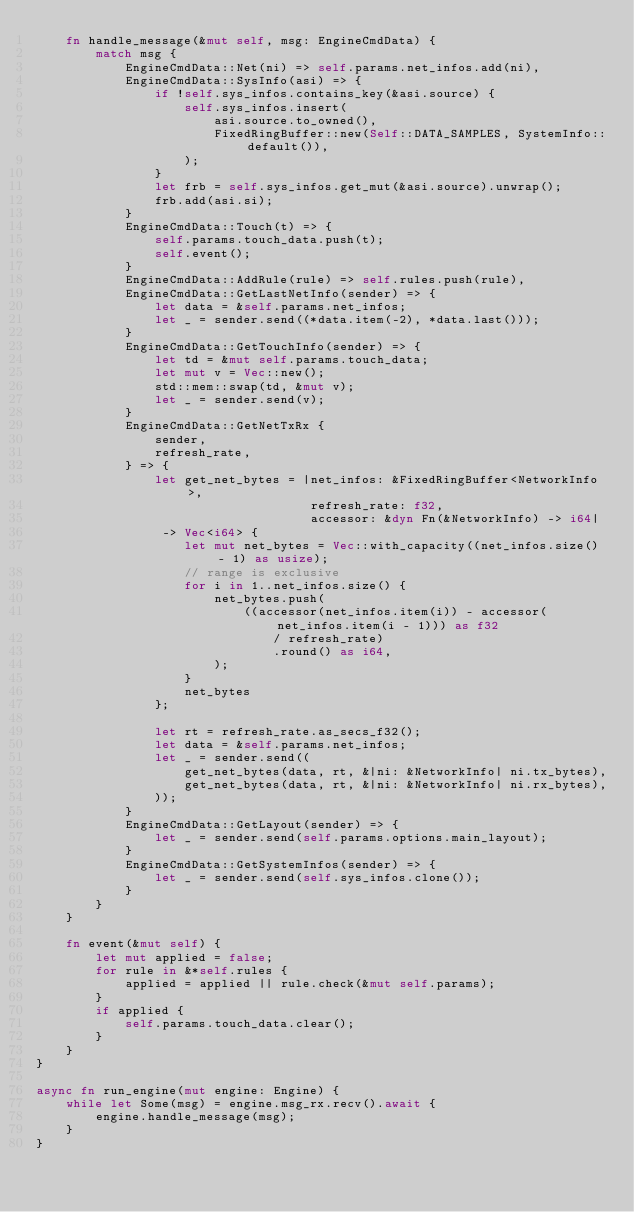Convert code to text. <code><loc_0><loc_0><loc_500><loc_500><_Rust_>    fn handle_message(&mut self, msg: EngineCmdData) {
        match msg {
            EngineCmdData::Net(ni) => self.params.net_infos.add(ni),
            EngineCmdData::SysInfo(asi) => {
                if !self.sys_infos.contains_key(&asi.source) {
                    self.sys_infos.insert(
                        asi.source.to_owned(),
                        FixedRingBuffer::new(Self::DATA_SAMPLES, SystemInfo::default()),
                    );
                }
                let frb = self.sys_infos.get_mut(&asi.source).unwrap();
                frb.add(asi.si);
            }
            EngineCmdData::Touch(t) => {
                self.params.touch_data.push(t);
                self.event();
            }
            EngineCmdData::AddRule(rule) => self.rules.push(rule),
            EngineCmdData::GetLastNetInfo(sender) => {
                let data = &self.params.net_infos;
                let _ = sender.send((*data.item(-2), *data.last()));
            }
            EngineCmdData::GetTouchInfo(sender) => {
                let td = &mut self.params.touch_data;
                let mut v = Vec::new();
                std::mem::swap(td, &mut v);
                let _ = sender.send(v);
            }
            EngineCmdData::GetNetTxRx {
                sender,
                refresh_rate,
            } => {
                let get_net_bytes = |net_infos: &FixedRingBuffer<NetworkInfo>,
                                     refresh_rate: f32,
                                     accessor: &dyn Fn(&NetworkInfo) -> i64|
                 -> Vec<i64> {
                    let mut net_bytes = Vec::with_capacity((net_infos.size() - 1) as usize);
                    // range is exclusive
                    for i in 1..net_infos.size() {
                        net_bytes.push(
                            ((accessor(net_infos.item(i)) - accessor(net_infos.item(i - 1))) as f32
                                / refresh_rate)
                                .round() as i64,
                        );
                    }
                    net_bytes
                };

                let rt = refresh_rate.as_secs_f32();
                let data = &self.params.net_infos;
                let _ = sender.send((
                    get_net_bytes(data, rt, &|ni: &NetworkInfo| ni.tx_bytes),
                    get_net_bytes(data, rt, &|ni: &NetworkInfo| ni.rx_bytes),
                ));
            }
            EngineCmdData::GetLayout(sender) => {
                let _ = sender.send(self.params.options.main_layout);
            }
            EngineCmdData::GetSystemInfos(sender) => {
                let _ = sender.send(self.sys_infos.clone());
            }
        }
    }

    fn event(&mut self) {
        let mut applied = false;
        for rule in &*self.rules {
            applied = applied || rule.check(&mut self.params);
        }
        if applied {
            self.params.touch_data.clear();
        }
    }
}

async fn run_engine(mut engine: Engine) {
    while let Some(msg) = engine.msg_rx.recv().await {
        engine.handle_message(msg);
    }
}
</code> 